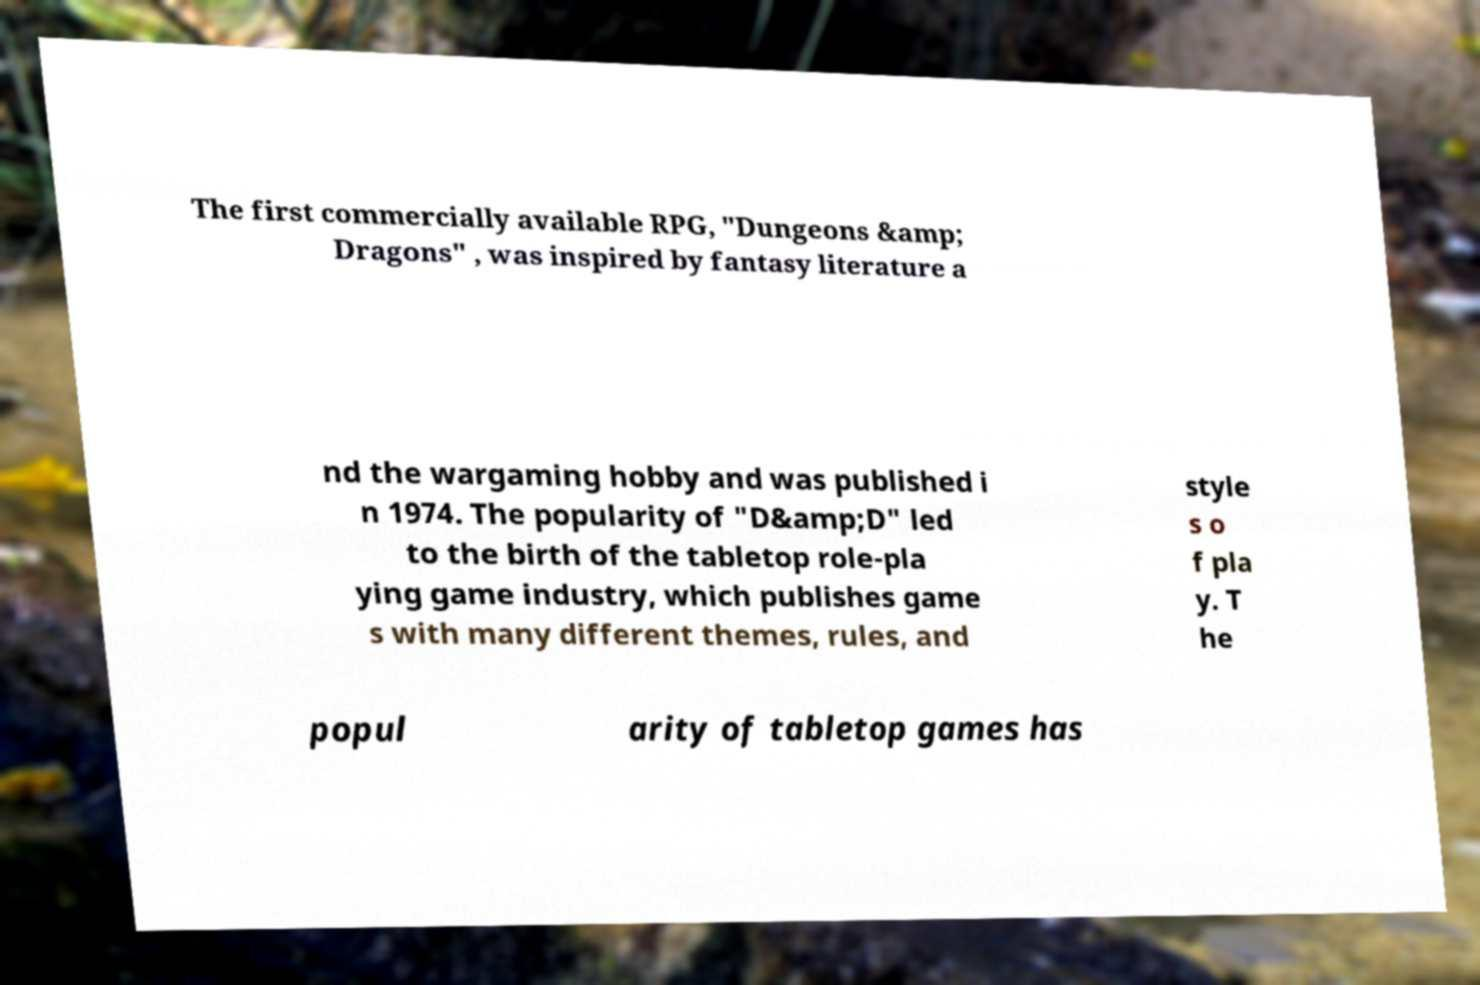For documentation purposes, I need the text within this image transcribed. Could you provide that? The first commercially available RPG, "Dungeons &amp; Dragons" , was inspired by fantasy literature a nd the wargaming hobby and was published i n 1974. The popularity of "D&amp;D" led to the birth of the tabletop role-pla ying game industry, which publishes game s with many different themes, rules, and style s o f pla y. T he popul arity of tabletop games has 